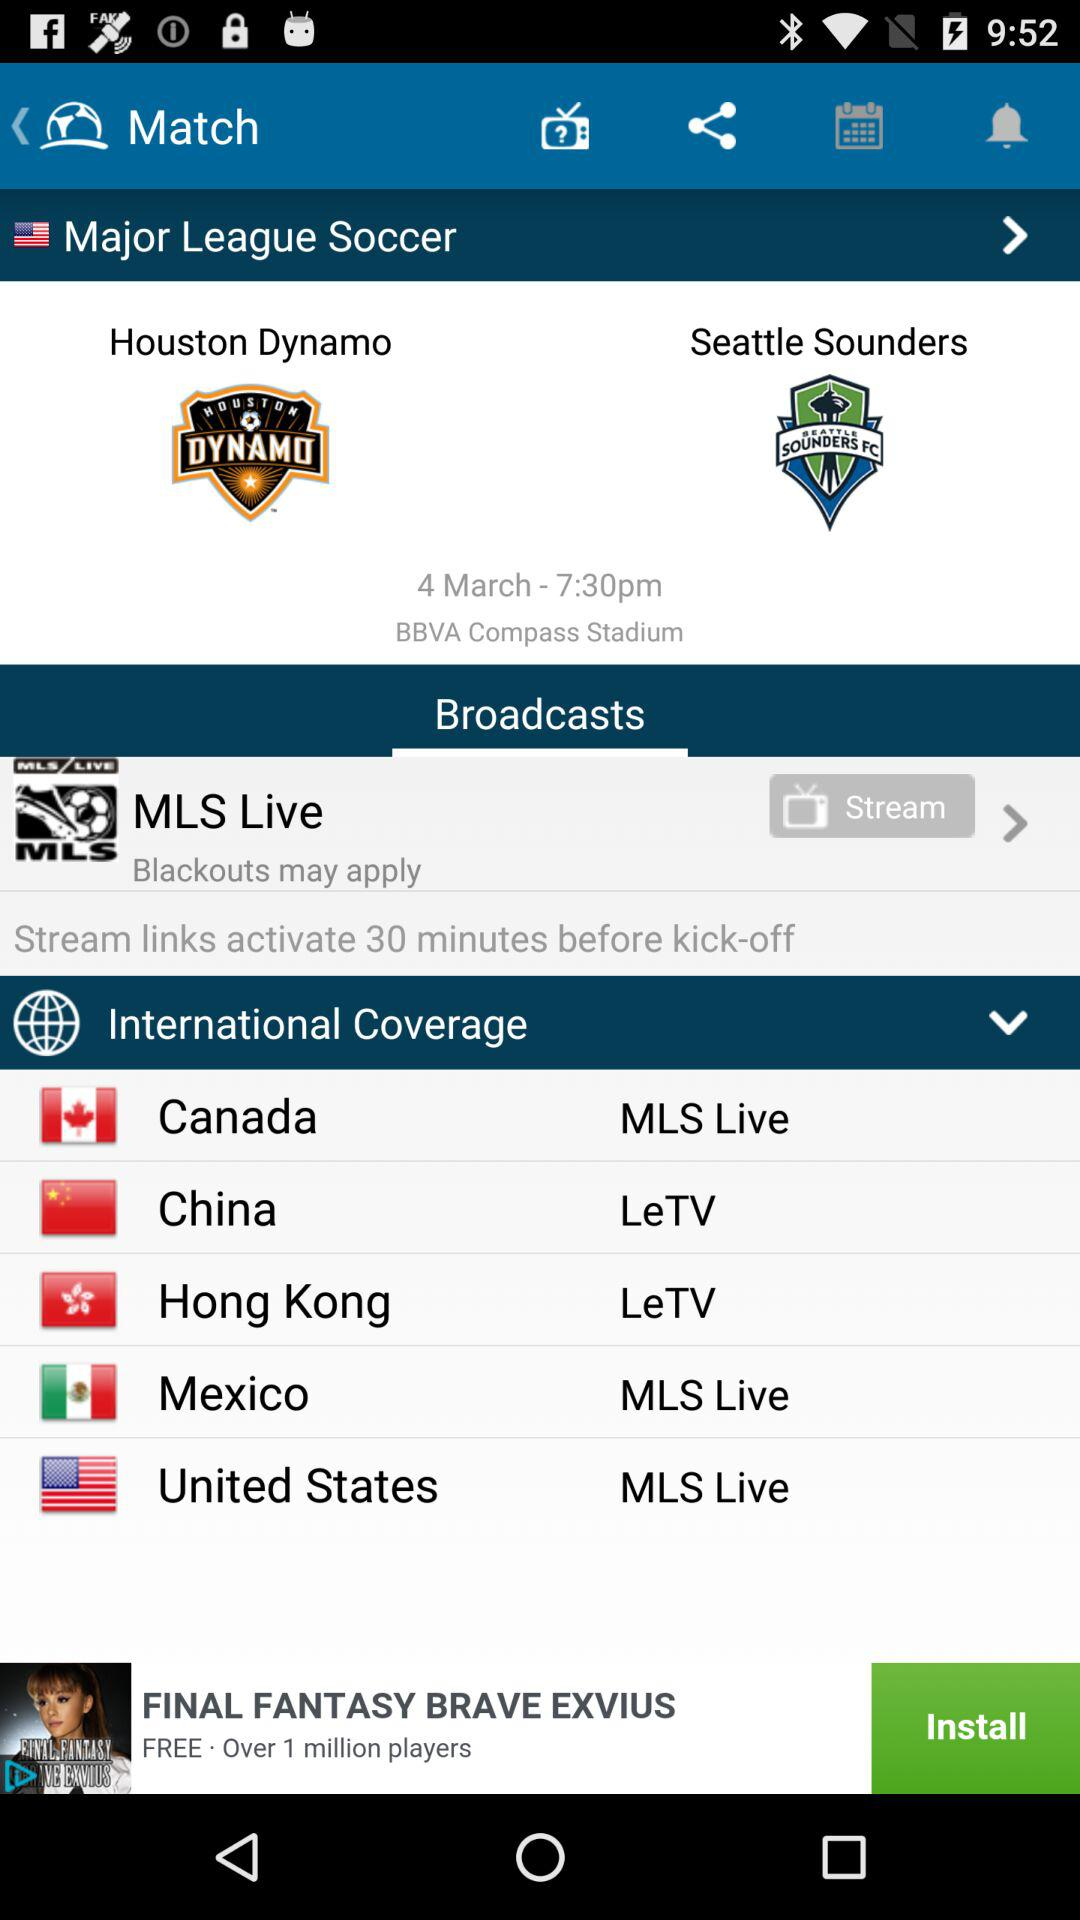Who will broadcast the match? The match will be broadcast by "MLS" live. 